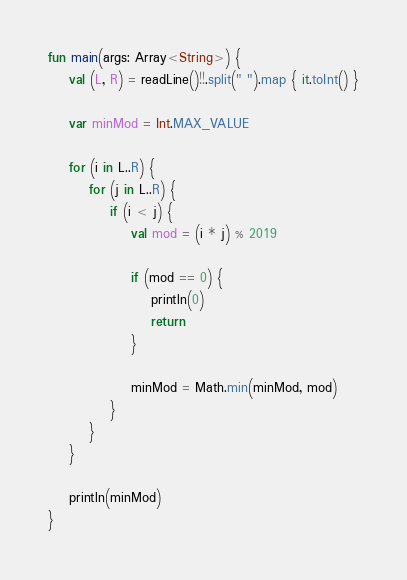Convert code to text. <code><loc_0><loc_0><loc_500><loc_500><_Kotlin_>fun main(args: Array<String>) {
    val (L, R) = readLine()!!.split(" ").map { it.toInt() }

    var minMod = Int.MAX_VALUE

    for (i in L..R) {
        for (j in L..R) {
            if (i < j) {
                val mod = (i * j) % 2019

                if (mod == 0) {
                    println(0)
                    return
                }

                minMod = Math.min(minMod, mod)
            }
        }
    }

    println(minMod)
}
</code> 